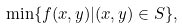<formula> <loc_0><loc_0><loc_500><loc_500>\min \{ f ( x , y ) | ( x , y ) \in S \} ,</formula> 